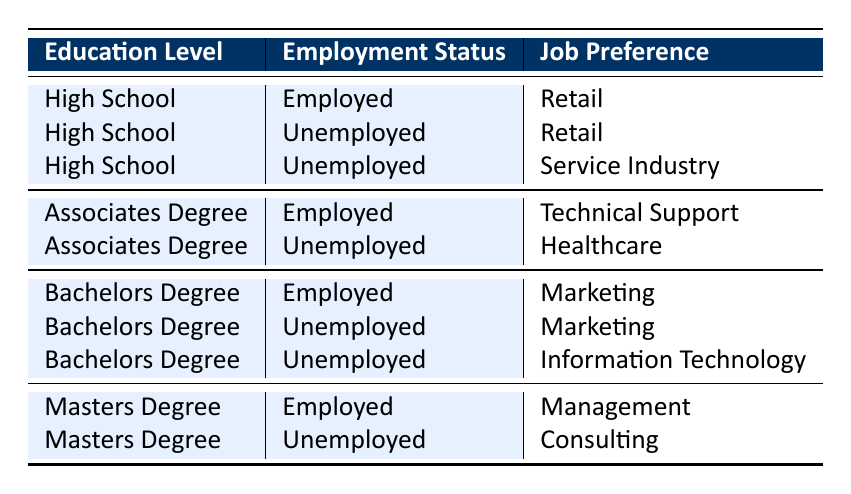What job preference is listed for individuals with a Bachelor's Degree who are unemployed? The table shows that individuals with a Bachelor's Degree who are unemployed have two job preferences listed: Marketing and Information Technology.
Answer: Marketing, Information Technology How many job preferences do unemployed individuals with a High School education have? For individuals with a High School education who are unemployed, there are two job preferences listed: Retail and Service Industry, which means there are a total of 2 preferences.
Answer: 2 Is there any job preference listed for unemployed individuals with an Associates Degree? There is one job preference listed for unemployed individuals with an Associates Degree, which is Healthcare. Thus, the statement is true.
Answer: Yes What is the total number of job preferences for each education level when comparing unemployed to employed individuals? For High School: 2 (unemployed) + 1 (employed) = 3; Associates Degree: 1 (unemployed) + 1 (employed) = 2; Bachelors Degree: 2 (unemployed) + 1 (employed) = 3; Masters Degree: 1 (unemployed) + 1 (employed) = 2. The total job preferences when comparing both groups is 3 + 2 + 3 + 2 = 10.
Answer: 10 What percentage of job preferences are for the Service Industry among unemployed individuals? There are a total of 2 job preferences for unemployed individuals according to their education levels (Retail and Service Industry), with 1 of those being Service Industry. Thus, the percentage is (1/2) * 100 = 50%.
Answer: 50% 